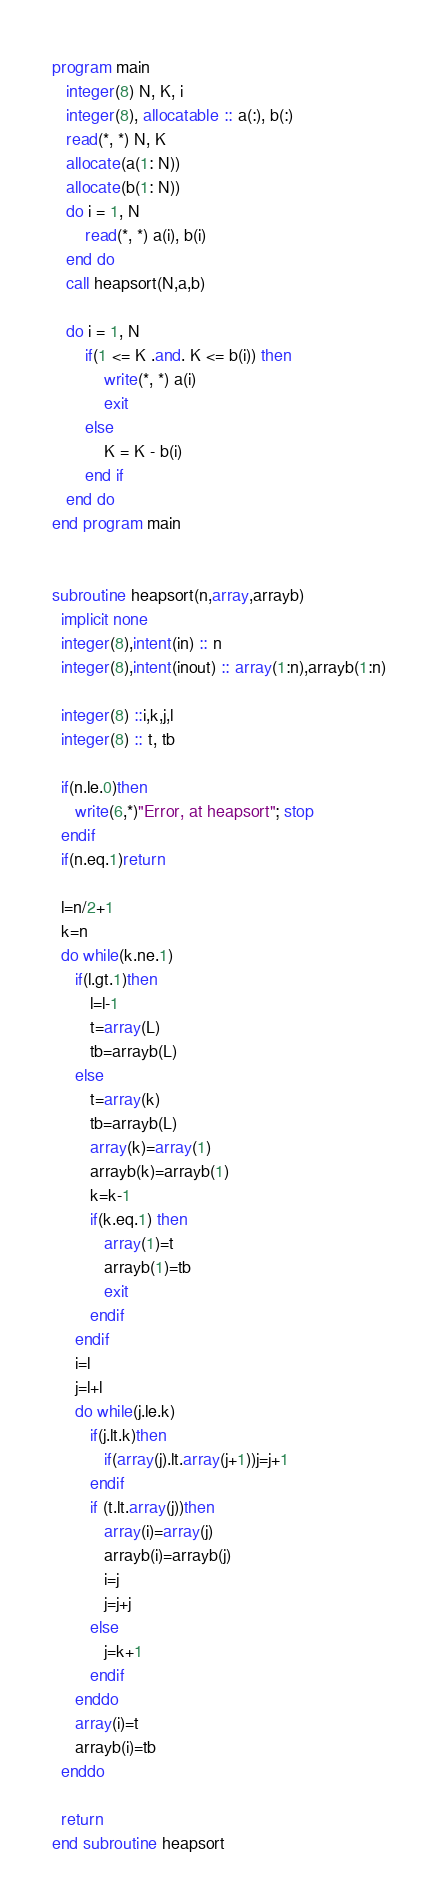Convert code to text. <code><loc_0><loc_0><loc_500><loc_500><_FORTRAN_>program main
   integer(8) N, K, i
   integer(8), allocatable :: a(:), b(:)
   read(*, *) N, K
   allocate(a(1: N))
   allocate(b(1: N))
   do i = 1, N
       read(*, *) a(i), b(i)
   end do
   call heapsort(N,a,b)

   do i = 1, N
       if(1 <= K .and. K <= b(i)) then
	       write(*, *) a(i)
	       exit
	   else
	       K = K - b(i)
	   end if
   end do
end program main


subroutine heapsort(n,array,arrayb)
  implicit none
  integer(8),intent(in) :: n
  integer(8),intent(inout) :: array(1:n),arrayb(1:n)
  
  integer(8) ::i,k,j,l
  integer(8) :: t, tb
  
  if(n.le.0)then
     write(6,*)"Error, at heapsort"; stop
  endif
  if(n.eq.1)return

  l=n/2+1
  k=n
  do while(k.ne.1)
     if(l.gt.1)then
        l=l-1
        t=array(L)
		tb=arrayb(L)
     else
        t=array(k)
		tb=arrayb(L)
        array(k)=array(1)
		arrayb(k)=arrayb(1)
        k=k-1
        if(k.eq.1) then
           array(1)=t
		   arrayb(1)=tb
           exit
        endif
     endif
     i=l
     j=l+l
     do while(j.le.k)
        if(j.lt.k)then
           if(array(j).lt.array(j+1))j=j+1
        endif
        if (t.lt.array(j))then
           array(i)=array(j)
		   arrayb(i)=arrayb(j)
           i=j
           j=j+j
        else
           j=k+1
        endif
     enddo
     array(i)=t
	 arrayb(i)=tb
  enddo

  return
end subroutine heapsort</code> 